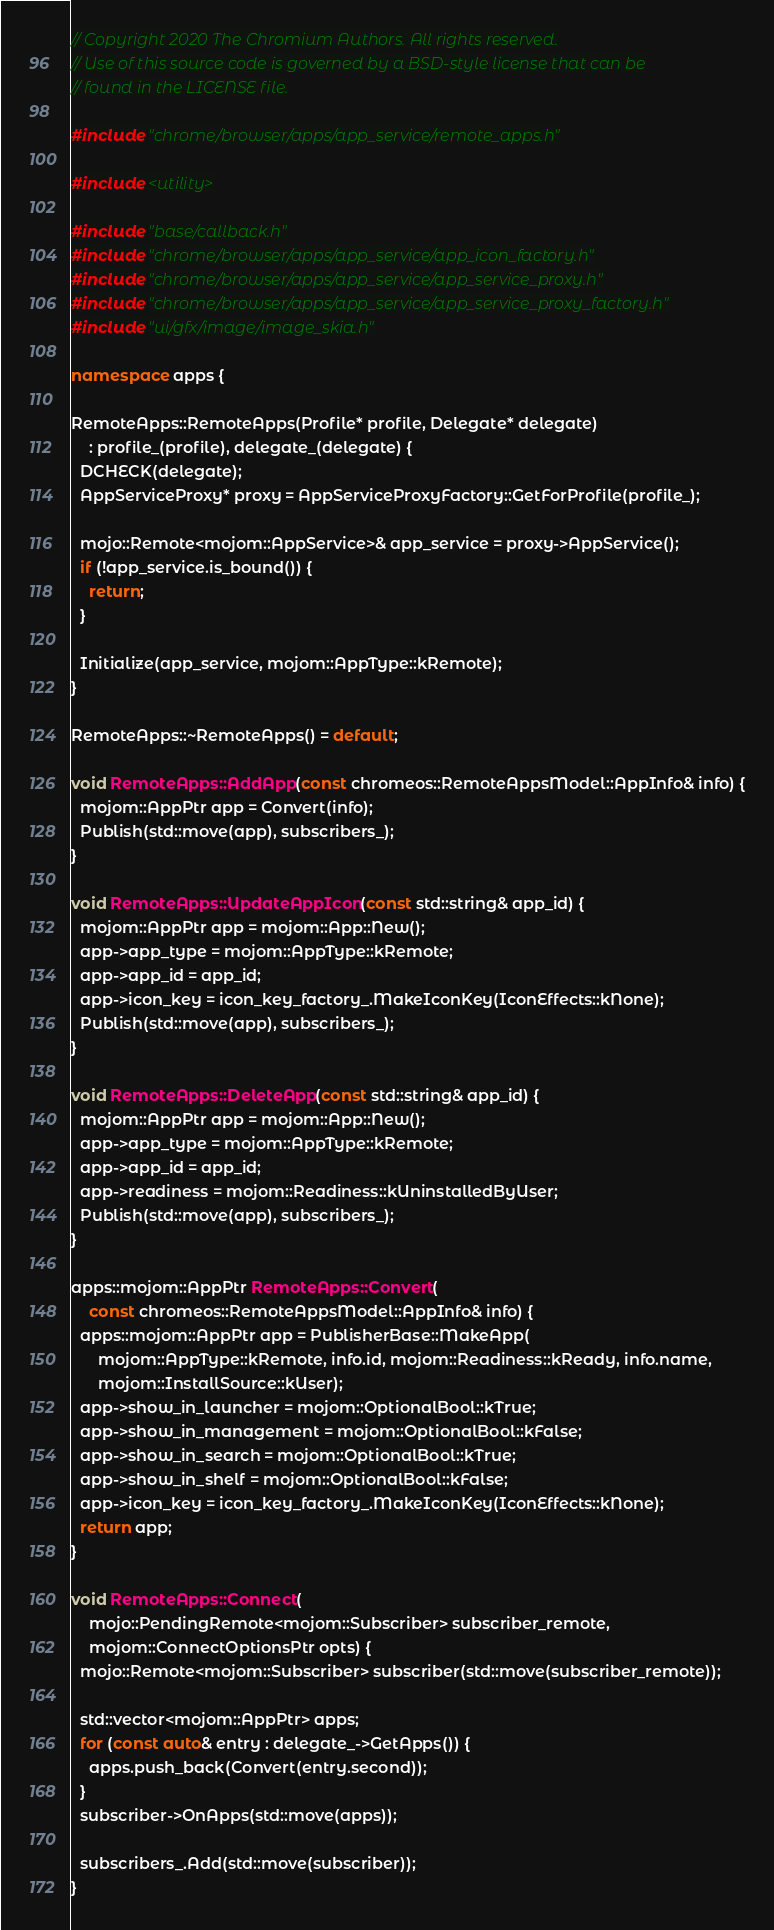Convert code to text. <code><loc_0><loc_0><loc_500><loc_500><_C++_>// Copyright 2020 The Chromium Authors. All rights reserved.
// Use of this source code is governed by a BSD-style license that can be
// found in the LICENSE file.

#include "chrome/browser/apps/app_service/remote_apps.h"

#include <utility>

#include "base/callback.h"
#include "chrome/browser/apps/app_service/app_icon_factory.h"
#include "chrome/browser/apps/app_service/app_service_proxy.h"
#include "chrome/browser/apps/app_service/app_service_proxy_factory.h"
#include "ui/gfx/image/image_skia.h"

namespace apps {

RemoteApps::RemoteApps(Profile* profile, Delegate* delegate)
    : profile_(profile), delegate_(delegate) {
  DCHECK(delegate);
  AppServiceProxy* proxy = AppServiceProxyFactory::GetForProfile(profile_);

  mojo::Remote<mojom::AppService>& app_service = proxy->AppService();
  if (!app_service.is_bound()) {
    return;
  }

  Initialize(app_service, mojom::AppType::kRemote);
}

RemoteApps::~RemoteApps() = default;

void RemoteApps::AddApp(const chromeos::RemoteAppsModel::AppInfo& info) {
  mojom::AppPtr app = Convert(info);
  Publish(std::move(app), subscribers_);
}

void RemoteApps::UpdateAppIcon(const std::string& app_id) {
  mojom::AppPtr app = mojom::App::New();
  app->app_type = mojom::AppType::kRemote;
  app->app_id = app_id;
  app->icon_key = icon_key_factory_.MakeIconKey(IconEffects::kNone);
  Publish(std::move(app), subscribers_);
}

void RemoteApps::DeleteApp(const std::string& app_id) {
  mojom::AppPtr app = mojom::App::New();
  app->app_type = mojom::AppType::kRemote;
  app->app_id = app_id;
  app->readiness = mojom::Readiness::kUninstalledByUser;
  Publish(std::move(app), subscribers_);
}

apps::mojom::AppPtr RemoteApps::Convert(
    const chromeos::RemoteAppsModel::AppInfo& info) {
  apps::mojom::AppPtr app = PublisherBase::MakeApp(
      mojom::AppType::kRemote, info.id, mojom::Readiness::kReady, info.name,
      mojom::InstallSource::kUser);
  app->show_in_launcher = mojom::OptionalBool::kTrue;
  app->show_in_management = mojom::OptionalBool::kFalse;
  app->show_in_search = mojom::OptionalBool::kTrue;
  app->show_in_shelf = mojom::OptionalBool::kFalse;
  app->icon_key = icon_key_factory_.MakeIconKey(IconEffects::kNone);
  return app;
}

void RemoteApps::Connect(
    mojo::PendingRemote<mojom::Subscriber> subscriber_remote,
    mojom::ConnectOptionsPtr opts) {
  mojo::Remote<mojom::Subscriber> subscriber(std::move(subscriber_remote));

  std::vector<mojom::AppPtr> apps;
  for (const auto& entry : delegate_->GetApps()) {
    apps.push_back(Convert(entry.second));
  }
  subscriber->OnApps(std::move(apps));

  subscribers_.Add(std::move(subscriber));
}
</code> 